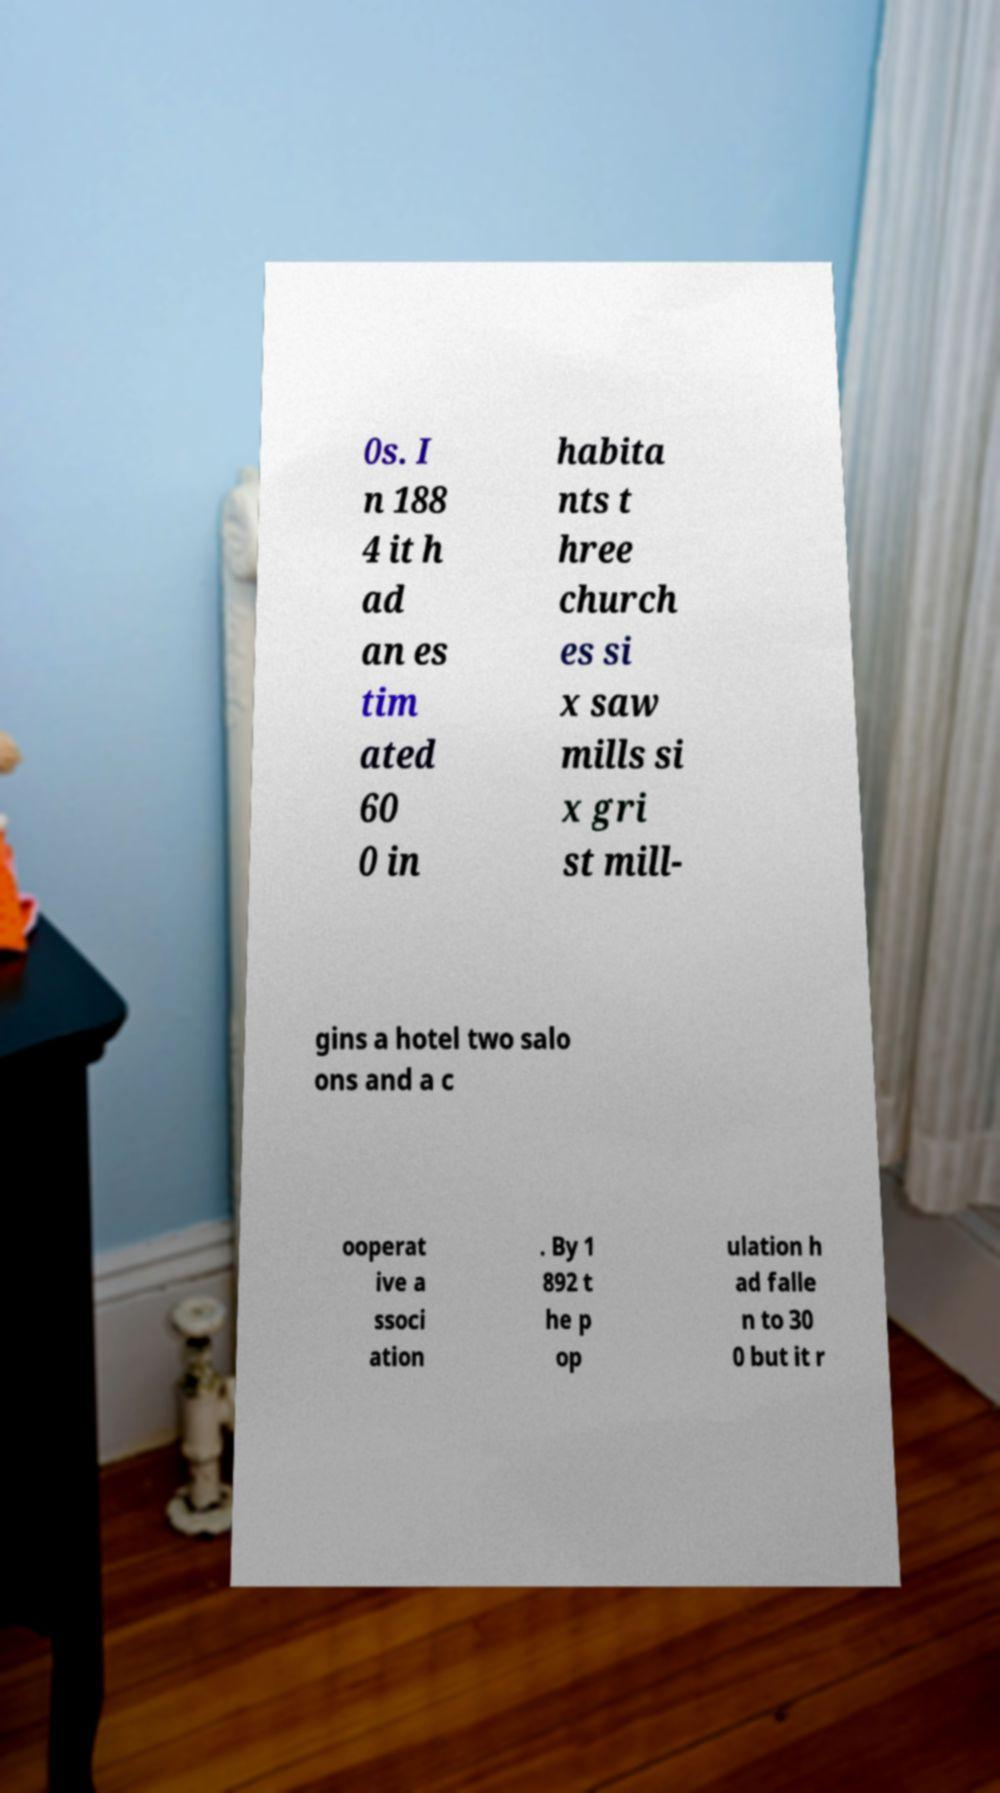Can you read and provide the text displayed in the image?This photo seems to have some interesting text. Can you extract and type it out for me? 0s. I n 188 4 it h ad an es tim ated 60 0 in habita nts t hree church es si x saw mills si x gri st mill- gins a hotel two salo ons and a c ooperat ive a ssoci ation . By 1 892 t he p op ulation h ad falle n to 30 0 but it r 